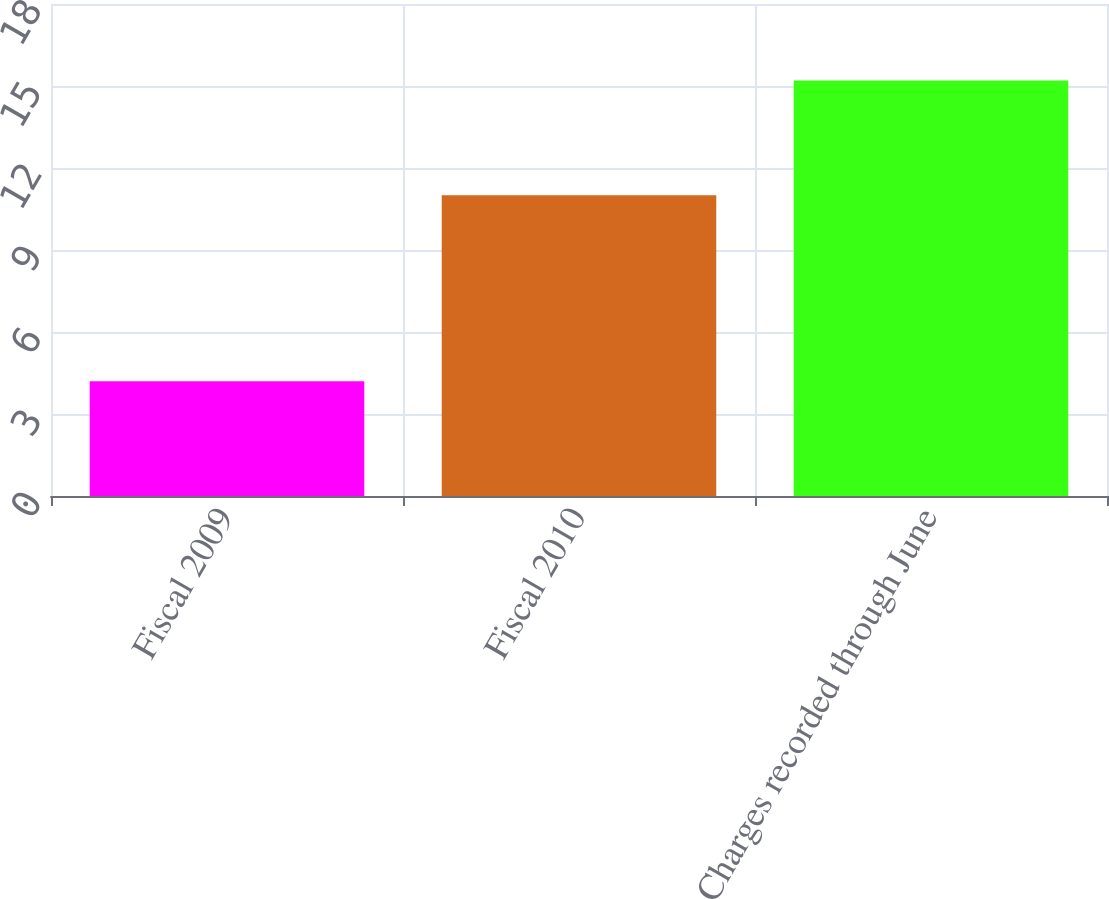Convert chart. <chart><loc_0><loc_0><loc_500><loc_500><bar_chart><fcel>Fiscal 2009<fcel>Fiscal 2010<fcel>Charges recorded through June<nl><fcel>4.2<fcel>11<fcel>15.2<nl></chart> 